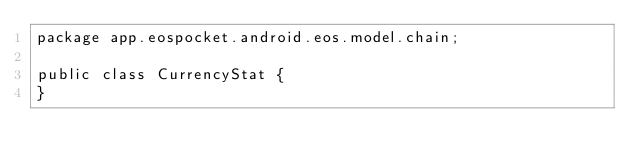Convert code to text. <code><loc_0><loc_0><loc_500><loc_500><_Java_>package app.eospocket.android.eos.model.chain;

public class CurrencyStat {
}
</code> 